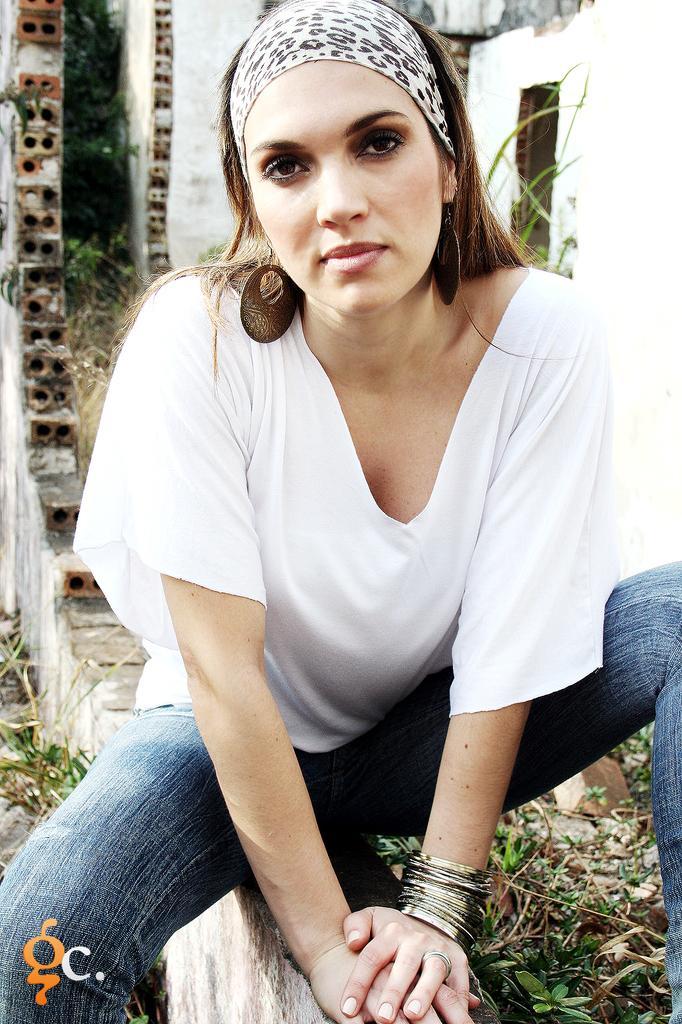Please provide a concise description of this image. This picture shows a woman seated and she wore a white T-shirt and a blue trouser and we see a cloth on the head and we see a old building on the back and we see a logo at the bottom left corner of the picture. 